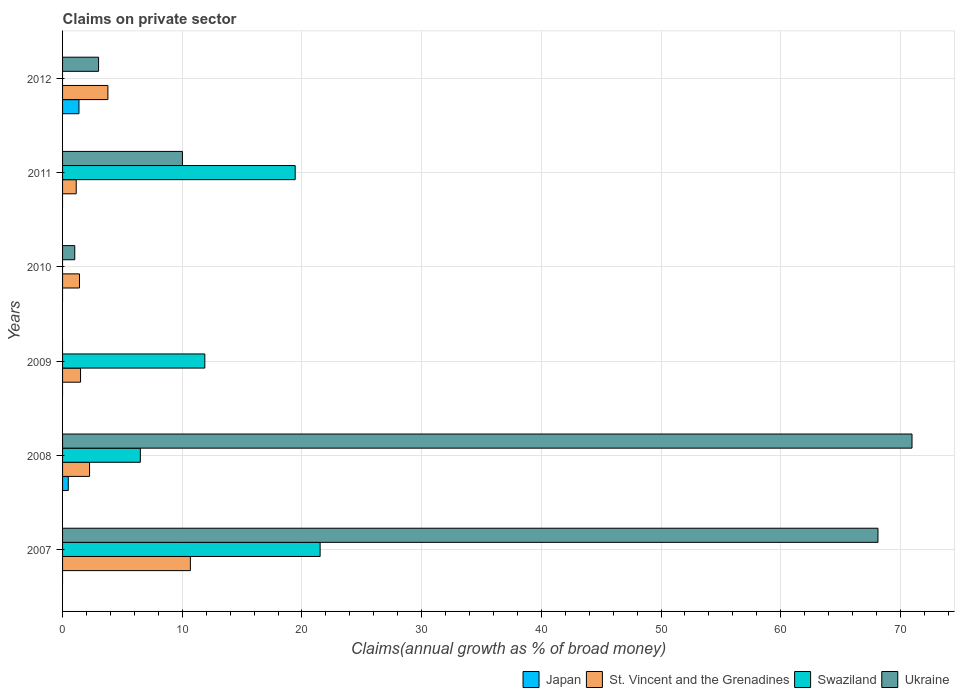How many groups of bars are there?
Your answer should be very brief. 6. Are the number of bars on each tick of the Y-axis equal?
Give a very brief answer. No. How many bars are there on the 3rd tick from the bottom?
Make the answer very short. 2. What is the label of the 1st group of bars from the top?
Provide a short and direct response. 2012. In how many cases, is the number of bars for a given year not equal to the number of legend labels?
Offer a terse response. 5. What is the percentage of broad money claimed on private sector in Swaziland in 2011?
Keep it short and to the point. 19.43. Across all years, what is the maximum percentage of broad money claimed on private sector in St. Vincent and the Grenadines?
Your answer should be very brief. 10.68. Across all years, what is the minimum percentage of broad money claimed on private sector in St. Vincent and the Grenadines?
Offer a very short reply. 1.14. What is the total percentage of broad money claimed on private sector in Ukraine in the graph?
Your answer should be compact. 153.14. What is the difference between the percentage of broad money claimed on private sector in St. Vincent and the Grenadines in 2009 and that in 2010?
Your answer should be very brief. 0.09. What is the difference between the percentage of broad money claimed on private sector in St. Vincent and the Grenadines in 2009 and the percentage of broad money claimed on private sector in Japan in 2012?
Offer a terse response. 0.13. What is the average percentage of broad money claimed on private sector in Japan per year?
Make the answer very short. 0.31. In the year 2008, what is the difference between the percentage of broad money claimed on private sector in Ukraine and percentage of broad money claimed on private sector in Swaziland?
Ensure brevity in your answer.  64.47. In how many years, is the percentage of broad money claimed on private sector in Ukraine greater than 22 %?
Offer a terse response. 2. What is the ratio of the percentage of broad money claimed on private sector in St. Vincent and the Grenadines in 2008 to that in 2012?
Give a very brief answer. 0.6. Is the percentage of broad money claimed on private sector in St. Vincent and the Grenadines in 2009 less than that in 2012?
Offer a terse response. Yes. What is the difference between the highest and the second highest percentage of broad money claimed on private sector in Ukraine?
Your response must be concise. 2.84. What is the difference between the highest and the lowest percentage of broad money claimed on private sector in Swaziland?
Make the answer very short. 21.52. In how many years, is the percentage of broad money claimed on private sector in Swaziland greater than the average percentage of broad money claimed on private sector in Swaziland taken over all years?
Offer a terse response. 3. Is the sum of the percentage of broad money claimed on private sector in St. Vincent and the Grenadines in 2007 and 2010 greater than the maximum percentage of broad money claimed on private sector in Swaziland across all years?
Give a very brief answer. No. How many bars are there?
Keep it short and to the point. 17. How many years are there in the graph?
Your answer should be very brief. 6. Does the graph contain any zero values?
Offer a terse response. Yes. Does the graph contain grids?
Ensure brevity in your answer.  Yes. Where does the legend appear in the graph?
Offer a terse response. Bottom right. How many legend labels are there?
Make the answer very short. 4. What is the title of the graph?
Keep it short and to the point. Claims on private sector. Does "Least developed countries" appear as one of the legend labels in the graph?
Your answer should be compact. No. What is the label or title of the X-axis?
Give a very brief answer. Claims(annual growth as % of broad money). What is the label or title of the Y-axis?
Your answer should be compact. Years. What is the Claims(annual growth as % of broad money) of Japan in 2007?
Your response must be concise. 0. What is the Claims(annual growth as % of broad money) of St. Vincent and the Grenadines in 2007?
Keep it short and to the point. 10.68. What is the Claims(annual growth as % of broad money) of Swaziland in 2007?
Offer a very short reply. 21.52. What is the Claims(annual growth as % of broad money) in Ukraine in 2007?
Your answer should be compact. 68.12. What is the Claims(annual growth as % of broad money) of Japan in 2008?
Your answer should be compact. 0.48. What is the Claims(annual growth as % of broad money) in St. Vincent and the Grenadines in 2008?
Your answer should be very brief. 2.26. What is the Claims(annual growth as % of broad money) in Swaziland in 2008?
Your response must be concise. 6.5. What is the Claims(annual growth as % of broad money) in Ukraine in 2008?
Provide a succinct answer. 70.97. What is the Claims(annual growth as % of broad money) in St. Vincent and the Grenadines in 2009?
Provide a succinct answer. 1.5. What is the Claims(annual growth as % of broad money) in Swaziland in 2009?
Offer a terse response. 11.89. What is the Claims(annual growth as % of broad money) of Ukraine in 2009?
Provide a succinct answer. 0. What is the Claims(annual growth as % of broad money) in St. Vincent and the Grenadines in 2010?
Offer a terse response. 1.41. What is the Claims(annual growth as % of broad money) in Swaziland in 2010?
Provide a succinct answer. 0. What is the Claims(annual growth as % of broad money) of Ukraine in 2010?
Provide a succinct answer. 1.02. What is the Claims(annual growth as % of broad money) of St. Vincent and the Grenadines in 2011?
Provide a succinct answer. 1.14. What is the Claims(annual growth as % of broad money) of Swaziland in 2011?
Offer a terse response. 19.43. What is the Claims(annual growth as % of broad money) of Ukraine in 2011?
Ensure brevity in your answer.  10.02. What is the Claims(annual growth as % of broad money) of Japan in 2012?
Your answer should be compact. 1.37. What is the Claims(annual growth as % of broad money) of St. Vincent and the Grenadines in 2012?
Give a very brief answer. 3.79. What is the Claims(annual growth as % of broad money) in Swaziland in 2012?
Make the answer very short. 0. What is the Claims(annual growth as % of broad money) of Ukraine in 2012?
Keep it short and to the point. 3.01. Across all years, what is the maximum Claims(annual growth as % of broad money) in Japan?
Give a very brief answer. 1.37. Across all years, what is the maximum Claims(annual growth as % of broad money) in St. Vincent and the Grenadines?
Keep it short and to the point. 10.68. Across all years, what is the maximum Claims(annual growth as % of broad money) of Swaziland?
Provide a short and direct response. 21.52. Across all years, what is the maximum Claims(annual growth as % of broad money) of Ukraine?
Give a very brief answer. 70.97. Across all years, what is the minimum Claims(annual growth as % of broad money) in St. Vincent and the Grenadines?
Make the answer very short. 1.14. Across all years, what is the minimum Claims(annual growth as % of broad money) of Swaziland?
Your response must be concise. 0. Across all years, what is the minimum Claims(annual growth as % of broad money) in Ukraine?
Your response must be concise. 0. What is the total Claims(annual growth as % of broad money) in Japan in the graph?
Ensure brevity in your answer.  1.85. What is the total Claims(annual growth as % of broad money) in St. Vincent and the Grenadines in the graph?
Your response must be concise. 20.78. What is the total Claims(annual growth as % of broad money) of Swaziland in the graph?
Your answer should be very brief. 59.34. What is the total Claims(annual growth as % of broad money) of Ukraine in the graph?
Give a very brief answer. 153.14. What is the difference between the Claims(annual growth as % of broad money) of St. Vincent and the Grenadines in 2007 and that in 2008?
Your response must be concise. 8.42. What is the difference between the Claims(annual growth as % of broad money) in Swaziland in 2007 and that in 2008?
Give a very brief answer. 15.02. What is the difference between the Claims(annual growth as % of broad money) in Ukraine in 2007 and that in 2008?
Keep it short and to the point. -2.84. What is the difference between the Claims(annual growth as % of broad money) in St. Vincent and the Grenadines in 2007 and that in 2009?
Ensure brevity in your answer.  9.18. What is the difference between the Claims(annual growth as % of broad money) of Swaziland in 2007 and that in 2009?
Keep it short and to the point. 9.63. What is the difference between the Claims(annual growth as % of broad money) of St. Vincent and the Grenadines in 2007 and that in 2010?
Ensure brevity in your answer.  9.26. What is the difference between the Claims(annual growth as % of broad money) of Ukraine in 2007 and that in 2010?
Provide a succinct answer. 67.11. What is the difference between the Claims(annual growth as % of broad money) of St. Vincent and the Grenadines in 2007 and that in 2011?
Keep it short and to the point. 9.54. What is the difference between the Claims(annual growth as % of broad money) in Swaziland in 2007 and that in 2011?
Keep it short and to the point. 2.08. What is the difference between the Claims(annual growth as % of broad money) of Ukraine in 2007 and that in 2011?
Ensure brevity in your answer.  58.11. What is the difference between the Claims(annual growth as % of broad money) in St. Vincent and the Grenadines in 2007 and that in 2012?
Your answer should be very brief. 6.89. What is the difference between the Claims(annual growth as % of broad money) in Ukraine in 2007 and that in 2012?
Offer a terse response. 65.12. What is the difference between the Claims(annual growth as % of broad money) of St. Vincent and the Grenadines in 2008 and that in 2009?
Your answer should be compact. 0.75. What is the difference between the Claims(annual growth as % of broad money) of Swaziland in 2008 and that in 2009?
Ensure brevity in your answer.  -5.39. What is the difference between the Claims(annual growth as % of broad money) in St. Vincent and the Grenadines in 2008 and that in 2010?
Provide a short and direct response. 0.84. What is the difference between the Claims(annual growth as % of broad money) of Ukraine in 2008 and that in 2010?
Offer a very short reply. 69.95. What is the difference between the Claims(annual growth as % of broad money) in St. Vincent and the Grenadines in 2008 and that in 2011?
Your response must be concise. 1.12. What is the difference between the Claims(annual growth as % of broad money) in Swaziland in 2008 and that in 2011?
Your response must be concise. -12.94. What is the difference between the Claims(annual growth as % of broad money) of Ukraine in 2008 and that in 2011?
Give a very brief answer. 60.95. What is the difference between the Claims(annual growth as % of broad money) of Japan in 2008 and that in 2012?
Your answer should be very brief. -0.89. What is the difference between the Claims(annual growth as % of broad money) in St. Vincent and the Grenadines in 2008 and that in 2012?
Your response must be concise. -1.53. What is the difference between the Claims(annual growth as % of broad money) in Ukraine in 2008 and that in 2012?
Provide a short and direct response. 67.96. What is the difference between the Claims(annual growth as % of broad money) of St. Vincent and the Grenadines in 2009 and that in 2010?
Make the answer very short. 0.09. What is the difference between the Claims(annual growth as % of broad money) in St. Vincent and the Grenadines in 2009 and that in 2011?
Keep it short and to the point. 0.36. What is the difference between the Claims(annual growth as % of broad money) of Swaziland in 2009 and that in 2011?
Your answer should be compact. -7.55. What is the difference between the Claims(annual growth as % of broad money) in St. Vincent and the Grenadines in 2009 and that in 2012?
Make the answer very short. -2.28. What is the difference between the Claims(annual growth as % of broad money) in St. Vincent and the Grenadines in 2010 and that in 2011?
Your answer should be very brief. 0.27. What is the difference between the Claims(annual growth as % of broad money) of Ukraine in 2010 and that in 2011?
Offer a very short reply. -9. What is the difference between the Claims(annual growth as % of broad money) in St. Vincent and the Grenadines in 2010 and that in 2012?
Make the answer very short. -2.37. What is the difference between the Claims(annual growth as % of broad money) in Ukraine in 2010 and that in 2012?
Your answer should be compact. -1.99. What is the difference between the Claims(annual growth as % of broad money) in St. Vincent and the Grenadines in 2011 and that in 2012?
Your response must be concise. -2.65. What is the difference between the Claims(annual growth as % of broad money) of Ukraine in 2011 and that in 2012?
Your answer should be compact. 7.01. What is the difference between the Claims(annual growth as % of broad money) of St. Vincent and the Grenadines in 2007 and the Claims(annual growth as % of broad money) of Swaziland in 2008?
Make the answer very short. 4.18. What is the difference between the Claims(annual growth as % of broad money) of St. Vincent and the Grenadines in 2007 and the Claims(annual growth as % of broad money) of Ukraine in 2008?
Provide a succinct answer. -60.29. What is the difference between the Claims(annual growth as % of broad money) in Swaziland in 2007 and the Claims(annual growth as % of broad money) in Ukraine in 2008?
Offer a terse response. -49.45. What is the difference between the Claims(annual growth as % of broad money) of St. Vincent and the Grenadines in 2007 and the Claims(annual growth as % of broad money) of Swaziland in 2009?
Provide a succinct answer. -1.21. What is the difference between the Claims(annual growth as % of broad money) in St. Vincent and the Grenadines in 2007 and the Claims(annual growth as % of broad money) in Ukraine in 2010?
Keep it short and to the point. 9.66. What is the difference between the Claims(annual growth as % of broad money) in Swaziland in 2007 and the Claims(annual growth as % of broad money) in Ukraine in 2010?
Provide a short and direct response. 20.5. What is the difference between the Claims(annual growth as % of broad money) of St. Vincent and the Grenadines in 2007 and the Claims(annual growth as % of broad money) of Swaziland in 2011?
Give a very brief answer. -8.76. What is the difference between the Claims(annual growth as % of broad money) of St. Vincent and the Grenadines in 2007 and the Claims(annual growth as % of broad money) of Ukraine in 2011?
Your answer should be very brief. 0.66. What is the difference between the Claims(annual growth as % of broad money) of Swaziland in 2007 and the Claims(annual growth as % of broad money) of Ukraine in 2011?
Give a very brief answer. 11.5. What is the difference between the Claims(annual growth as % of broad money) of St. Vincent and the Grenadines in 2007 and the Claims(annual growth as % of broad money) of Ukraine in 2012?
Ensure brevity in your answer.  7.67. What is the difference between the Claims(annual growth as % of broad money) of Swaziland in 2007 and the Claims(annual growth as % of broad money) of Ukraine in 2012?
Your answer should be compact. 18.51. What is the difference between the Claims(annual growth as % of broad money) of Japan in 2008 and the Claims(annual growth as % of broad money) of St. Vincent and the Grenadines in 2009?
Your response must be concise. -1.02. What is the difference between the Claims(annual growth as % of broad money) in Japan in 2008 and the Claims(annual growth as % of broad money) in Swaziland in 2009?
Provide a succinct answer. -11.41. What is the difference between the Claims(annual growth as % of broad money) of St. Vincent and the Grenadines in 2008 and the Claims(annual growth as % of broad money) of Swaziland in 2009?
Ensure brevity in your answer.  -9.63. What is the difference between the Claims(annual growth as % of broad money) in Japan in 2008 and the Claims(annual growth as % of broad money) in St. Vincent and the Grenadines in 2010?
Offer a terse response. -0.94. What is the difference between the Claims(annual growth as % of broad money) in Japan in 2008 and the Claims(annual growth as % of broad money) in Ukraine in 2010?
Offer a terse response. -0.54. What is the difference between the Claims(annual growth as % of broad money) of St. Vincent and the Grenadines in 2008 and the Claims(annual growth as % of broad money) of Ukraine in 2010?
Your response must be concise. 1.24. What is the difference between the Claims(annual growth as % of broad money) in Swaziland in 2008 and the Claims(annual growth as % of broad money) in Ukraine in 2010?
Provide a succinct answer. 5.48. What is the difference between the Claims(annual growth as % of broad money) of Japan in 2008 and the Claims(annual growth as % of broad money) of St. Vincent and the Grenadines in 2011?
Keep it short and to the point. -0.66. What is the difference between the Claims(annual growth as % of broad money) in Japan in 2008 and the Claims(annual growth as % of broad money) in Swaziland in 2011?
Give a very brief answer. -18.96. What is the difference between the Claims(annual growth as % of broad money) of Japan in 2008 and the Claims(annual growth as % of broad money) of Ukraine in 2011?
Ensure brevity in your answer.  -9.54. What is the difference between the Claims(annual growth as % of broad money) in St. Vincent and the Grenadines in 2008 and the Claims(annual growth as % of broad money) in Swaziland in 2011?
Your answer should be compact. -17.18. What is the difference between the Claims(annual growth as % of broad money) in St. Vincent and the Grenadines in 2008 and the Claims(annual growth as % of broad money) in Ukraine in 2011?
Your answer should be compact. -7.76. What is the difference between the Claims(annual growth as % of broad money) in Swaziland in 2008 and the Claims(annual growth as % of broad money) in Ukraine in 2011?
Provide a short and direct response. -3.52. What is the difference between the Claims(annual growth as % of broad money) of Japan in 2008 and the Claims(annual growth as % of broad money) of St. Vincent and the Grenadines in 2012?
Provide a succinct answer. -3.31. What is the difference between the Claims(annual growth as % of broad money) in Japan in 2008 and the Claims(annual growth as % of broad money) in Ukraine in 2012?
Offer a terse response. -2.53. What is the difference between the Claims(annual growth as % of broad money) of St. Vincent and the Grenadines in 2008 and the Claims(annual growth as % of broad money) of Ukraine in 2012?
Your response must be concise. -0.75. What is the difference between the Claims(annual growth as % of broad money) of Swaziland in 2008 and the Claims(annual growth as % of broad money) of Ukraine in 2012?
Keep it short and to the point. 3.49. What is the difference between the Claims(annual growth as % of broad money) of St. Vincent and the Grenadines in 2009 and the Claims(annual growth as % of broad money) of Ukraine in 2010?
Give a very brief answer. 0.48. What is the difference between the Claims(annual growth as % of broad money) in Swaziland in 2009 and the Claims(annual growth as % of broad money) in Ukraine in 2010?
Give a very brief answer. 10.87. What is the difference between the Claims(annual growth as % of broad money) of St. Vincent and the Grenadines in 2009 and the Claims(annual growth as % of broad money) of Swaziland in 2011?
Provide a succinct answer. -17.93. What is the difference between the Claims(annual growth as % of broad money) of St. Vincent and the Grenadines in 2009 and the Claims(annual growth as % of broad money) of Ukraine in 2011?
Offer a very short reply. -8.51. What is the difference between the Claims(annual growth as % of broad money) of Swaziland in 2009 and the Claims(annual growth as % of broad money) of Ukraine in 2011?
Your answer should be compact. 1.87. What is the difference between the Claims(annual growth as % of broad money) in St. Vincent and the Grenadines in 2009 and the Claims(annual growth as % of broad money) in Ukraine in 2012?
Keep it short and to the point. -1.51. What is the difference between the Claims(annual growth as % of broad money) in Swaziland in 2009 and the Claims(annual growth as % of broad money) in Ukraine in 2012?
Your answer should be very brief. 8.88. What is the difference between the Claims(annual growth as % of broad money) of St. Vincent and the Grenadines in 2010 and the Claims(annual growth as % of broad money) of Swaziland in 2011?
Offer a very short reply. -18.02. What is the difference between the Claims(annual growth as % of broad money) in St. Vincent and the Grenadines in 2010 and the Claims(annual growth as % of broad money) in Ukraine in 2011?
Keep it short and to the point. -8.6. What is the difference between the Claims(annual growth as % of broad money) in St. Vincent and the Grenadines in 2010 and the Claims(annual growth as % of broad money) in Ukraine in 2012?
Your answer should be compact. -1.6. What is the difference between the Claims(annual growth as % of broad money) in St. Vincent and the Grenadines in 2011 and the Claims(annual growth as % of broad money) in Ukraine in 2012?
Keep it short and to the point. -1.87. What is the difference between the Claims(annual growth as % of broad money) in Swaziland in 2011 and the Claims(annual growth as % of broad money) in Ukraine in 2012?
Offer a very short reply. 16.43. What is the average Claims(annual growth as % of broad money) in Japan per year?
Ensure brevity in your answer.  0.31. What is the average Claims(annual growth as % of broad money) in St. Vincent and the Grenadines per year?
Your response must be concise. 3.46. What is the average Claims(annual growth as % of broad money) of Swaziland per year?
Provide a succinct answer. 9.89. What is the average Claims(annual growth as % of broad money) in Ukraine per year?
Keep it short and to the point. 25.52. In the year 2007, what is the difference between the Claims(annual growth as % of broad money) of St. Vincent and the Grenadines and Claims(annual growth as % of broad money) of Swaziland?
Ensure brevity in your answer.  -10.84. In the year 2007, what is the difference between the Claims(annual growth as % of broad money) in St. Vincent and the Grenadines and Claims(annual growth as % of broad money) in Ukraine?
Make the answer very short. -57.45. In the year 2007, what is the difference between the Claims(annual growth as % of broad money) of Swaziland and Claims(annual growth as % of broad money) of Ukraine?
Offer a very short reply. -46.61. In the year 2008, what is the difference between the Claims(annual growth as % of broad money) in Japan and Claims(annual growth as % of broad money) in St. Vincent and the Grenadines?
Provide a short and direct response. -1.78. In the year 2008, what is the difference between the Claims(annual growth as % of broad money) in Japan and Claims(annual growth as % of broad money) in Swaziland?
Make the answer very short. -6.02. In the year 2008, what is the difference between the Claims(annual growth as % of broad money) of Japan and Claims(annual growth as % of broad money) of Ukraine?
Offer a terse response. -70.49. In the year 2008, what is the difference between the Claims(annual growth as % of broad money) in St. Vincent and the Grenadines and Claims(annual growth as % of broad money) in Swaziland?
Ensure brevity in your answer.  -4.24. In the year 2008, what is the difference between the Claims(annual growth as % of broad money) of St. Vincent and the Grenadines and Claims(annual growth as % of broad money) of Ukraine?
Keep it short and to the point. -68.71. In the year 2008, what is the difference between the Claims(annual growth as % of broad money) in Swaziland and Claims(annual growth as % of broad money) in Ukraine?
Offer a very short reply. -64.47. In the year 2009, what is the difference between the Claims(annual growth as % of broad money) in St. Vincent and the Grenadines and Claims(annual growth as % of broad money) in Swaziland?
Provide a succinct answer. -10.38. In the year 2010, what is the difference between the Claims(annual growth as % of broad money) of St. Vincent and the Grenadines and Claims(annual growth as % of broad money) of Ukraine?
Ensure brevity in your answer.  0.39. In the year 2011, what is the difference between the Claims(annual growth as % of broad money) of St. Vincent and the Grenadines and Claims(annual growth as % of broad money) of Swaziland?
Your answer should be very brief. -18.29. In the year 2011, what is the difference between the Claims(annual growth as % of broad money) in St. Vincent and the Grenadines and Claims(annual growth as % of broad money) in Ukraine?
Provide a short and direct response. -8.88. In the year 2011, what is the difference between the Claims(annual growth as % of broad money) of Swaziland and Claims(annual growth as % of broad money) of Ukraine?
Your answer should be compact. 9.42. In the year 2012, what is the difference between the Claims(annual growth as % of broad money) in Japan and Claims(annual growth as % of broad money) in St. Vincent and the Grenadines?
Your response must be concise. -2.42. In the year 2012, what is the difference between the Claims(annual growth as % of broad money) in Japan and Claims(annual growth as % of broad money) in Ukraine?
Offer a very short reply. -1.64. In the year 2012, what is the difference between the Claims(annual growth as % of broad money) of St. Vincent and the Grenadines and Claims(annual growth as % of broad money) of Ukraine?
Provide a succinct answer. 0.78. What is the ratio of the Claims(annual growth as % of broad money) in St. Vincent and the Grenadines in 2007 to that in 2008?
Offer a terse response. 4.73. What is the ratio of the Claims(annual growth as % of broad money) in Swaziland in 2007 to that in 2008?
Offer a terse response. 3.31. What is the ratio of the Claims(annual growth as % of broad money) of Ukraine in 2007 to that in 2008?
Give a very brief answer. 0.96. What is the ratio of the Claims(annual growth as % of broad money) of St. Vincent and the Grenadines in 2007 to that in 2009?
Ensure brevity in your answer.  7.11. What is the ratio of the Claims(annual growth as % of broad money) of Swaziland in 2007 to that in 2009?
Ensure brevity in your answer.  1.81. What is the ratio of the Claims(annual growth as % of broad money) in St. Vincent and the Grenadines in 2007 to that in 2010?
Keep it short and to the point. 7.55. What is the ratio of the Claims(annual growth as % of broad money) in Ukraine in 2007 to that in 2010?
Offer a very short reply. 66.87. What is the ratio of the Claims(annual growth as % of broad money) of St. Vincent and the Grenadines in 2007 to that in 2011?
Your response must be concise. 9.36. What is the ratio of the Claims(annual growth as % of broad money) in Swaziland in 2007 to that in 2011?
Keep it short and to the point. 1.11. What is the ratio of the Claims(annual growth as % of broad money) in Ukraine in 2007 to that in 2011?
Give a very brief answer. 6.8. What is the ratio of the Claims(annual growth as % of broad money) of St. Vincent and the Grenadines in 2007 to that in 2012?
Make the answer very short. 2.82. What is the ratio of the Claims(annual growth as % of broad money) of Ukraine in 2007 to that in 2012?
Make the answer very short. 22.64. What is the ratio of the Claims(annual growth as % of broad money) in St. Vincent and the Grenadines in 2008 to that in 2009?
Provide a succinct answer. 1.5. What is the ratio of the Claims(annual growth as % of broad money) of Swaziland in 2008 to that in 2009?
Ensure brevity in your answer.  0.55. What is the ratio of the Claims(annual growth as % of broad money) of St. Vincent and the Grenadines in 2008 to that in 2010?
Your answer should be compact. 1.6. What is the ratio of the Claims(annual growth as % of broad money) of Ukraine in 2008 to that in 2010?
Keep it short and to the point. 69.66. What is the ratio of the Claims(annual growth as % of broad money) of St. Vincent and the Grenadines in 2008 to that in 2011?
Keep it short and to the point. 1.98. What is the ratio of the Claims(annual growth as % of broad money) in Swaziland in 2008 to that in 2011?
Ensure brevity in your answer.  0.33. What is the ratio of the Claims(annual growth as % of broad money) of Ukraine in 2008 to that in 2011?
Your answer should be very brief. 7.09. What is the ratio of the Claims(annual growth as % of broad money) of Japan in 2008 to that in 2012?
Ensure brevity in your answer.  0.35. What is the ratio of the Claims(annual growth as % of broad money) in St. Vincent and the Grenadines in 2008 to that in 2012?
Keep it short and to the point. 0.6. What is the ratio of the Claims(annual growth as % of broad money) in Ukraine in 2008 to that in 2012?
Provide a short and direct response. 23.59. What is the ratio of the Claims(annual growth as % of broad money) in St. Vincent and the Grenadines in 2009 to that in 2010?
Your response must be concise. 1.06. What is the ratio of the Claims(annual growth as % of broad money) in St. Vincent and the Grenadines in 2009 to that in 2011?
Provide a succinct answer. 1.32. What is the ratio of the Claims(annual growth as % of broad money) in Swaziland in 2009 to that in 2011?
Keep it short and to the point. 0.61. What is the ratio of the Claims(annual growth as % of broad money) in St. Vincent and the Grenadines in 2009 to that in 2012?
Provide a short and direct response. 0.4. What is the ratio of the Claims(annual growth as % of broad money) of St. Vincent and the Grenadines in 2010 to that in 2011?
Provide a succinct answer. 1.24. What is the ratio of the Claims(annual growth as % of broad money) in Ukraine in 2010 to that in 2011?
Make the answer very short. 0.1. What is the ratio of the Claims(annual growth as % of broad money) in St. Vincent and the Grenadines in 2010 to that in 2012?
Give a very brief answer. 0.37. What is the ratio of the Claims(annual growth as % of broad money) in Ukraine in 2010 to that in 2012?
Your response must be concise. 0.34. What is the ratio of the Claims(annual growth as % of broad money) in St. Vincent and the Grenadines in 2011 to that in 2012?
Your answer should be compact. 0.3. What is the ratio of the Claims(annual growth as % of broad money) in Ukraine in 2011 to that in 2012?
Make the answer very short. 3.33. What is the difference between the highest and the second highest Claims(annual growth as % of broad money) in St. Vincent and the Grenadines?
Provide a succinct answer. 6.89. What is the difference between the highest and the second highest Claims(annual growth as % of broad money) in Swaziland?
Make the answer very short. 2.08. What is the difference between the highest and the second highest Claims(annual growth as % of broad money) in Ukraine?
Provide a succinct answer. 2.84. What is the difference between the highest and the lowest Claims(annual growth as % of broad money) in Japan?
Make the answer very short. 1.37. What is the difference between the highest and the lowest Claims(annual growth as % of broad money) of St. Vincent and the Grenadines?
Offer a terse response. 9.54. What is the difference between the highest and the lowest Claims(annual growth as % of broad money) in Swaziland?
Provide a short and direct response. 21.52. What is the difference between the highest and the lowest Claims(annual growth as % of broad money) of Ukraine?
Your response must be concise. 70.97. 